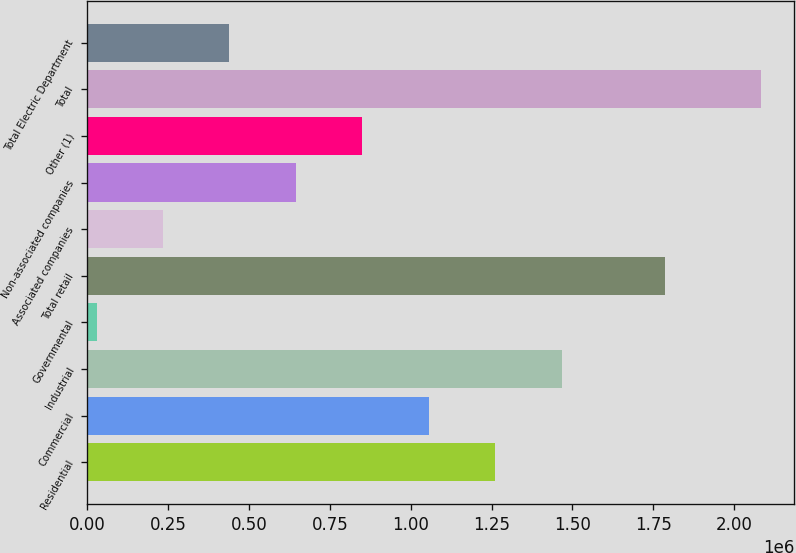<chart> <loc_0><loc_0><loc_500><loc_500><bar_chart><fcel>Residential<fcel>Commercial<fcel>Industrial<fcel>Governmental<fcel>Total retail<fcel>Associated companies<fcel>Non-associated companies<fcel>Other (1)<fcel>Total<fcel>Total Electric Department<nl><fcel>1.2608e+06<fcel>1.05542e+06<fcel>1.46619e+06<fcel>28475<fcel>1.78542e+06<fcel>233863<fcel>644640<fcel>850028<fcel>2.08236e+06<fcel>439252<nl></chart> 